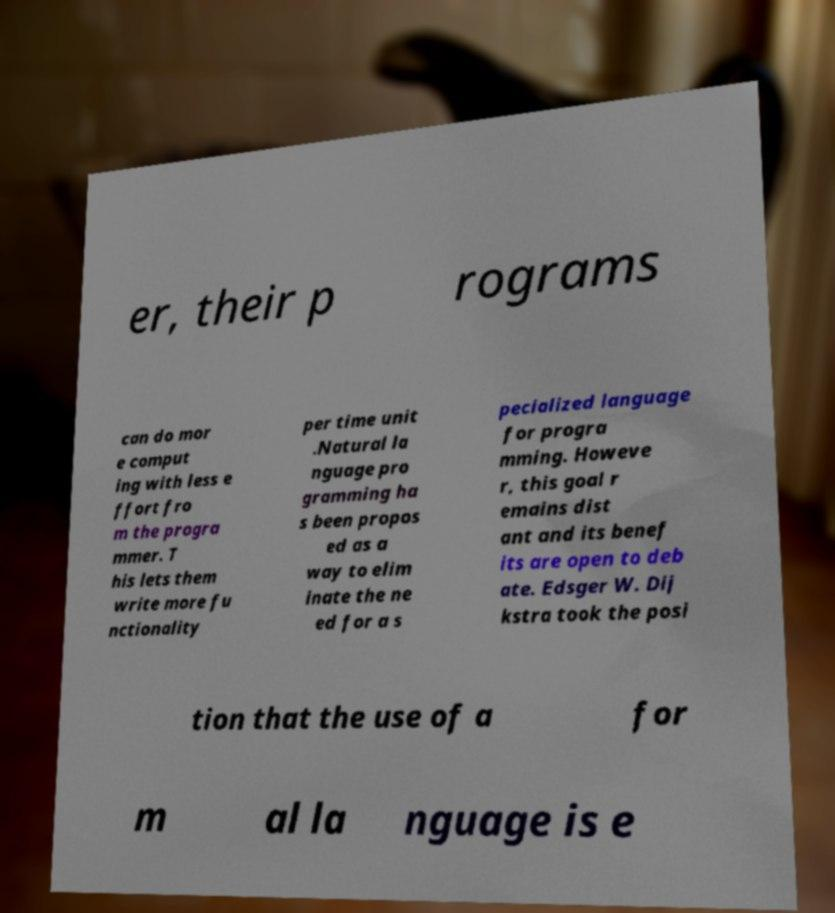I need the written content from this picture converted into text. Can you do that? er, their p rograms can do mor e comput ing with less e ffort fro m the progra mmer. T his lets them write more fu nctionality per time unit .Natural la nguage pro gramming ha s been propos ed as a way to elim inate the ne ed for a s pecialized language for progra mming. Howeve r, this goal r emains dist ant and its benef its are open to deb ate. Edsger W. Dij kstra took the posi tion that the use of a for m al la nguage is e 